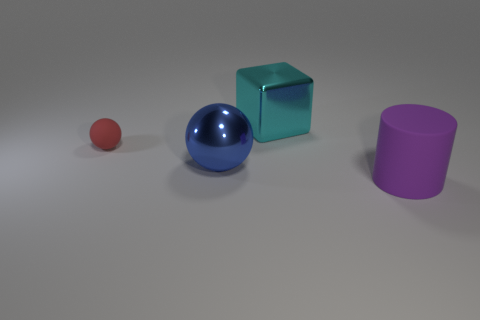Add 1 small red matte objects. How many objects exist? 5 Subtract all blocks. How many objects are left? 3 Add 3 purple balls. How many purple balls exist? 3 Subtract 0 brown cylinders. How many objects are left? 4 Subtract 1 cylinders. How many cylinders are left? 0 Subtract all yellow cylinders. Subtract all brown balls. How many cylinders are left? 1 Subtract all purple cylinders. How many blue balls are left? 1 Subtract all yellow objects. Subtract all blue metallic spheres. How many objects are left? 3 Add 1 large metallic blocks. How many large metallic blocks are left? 2 